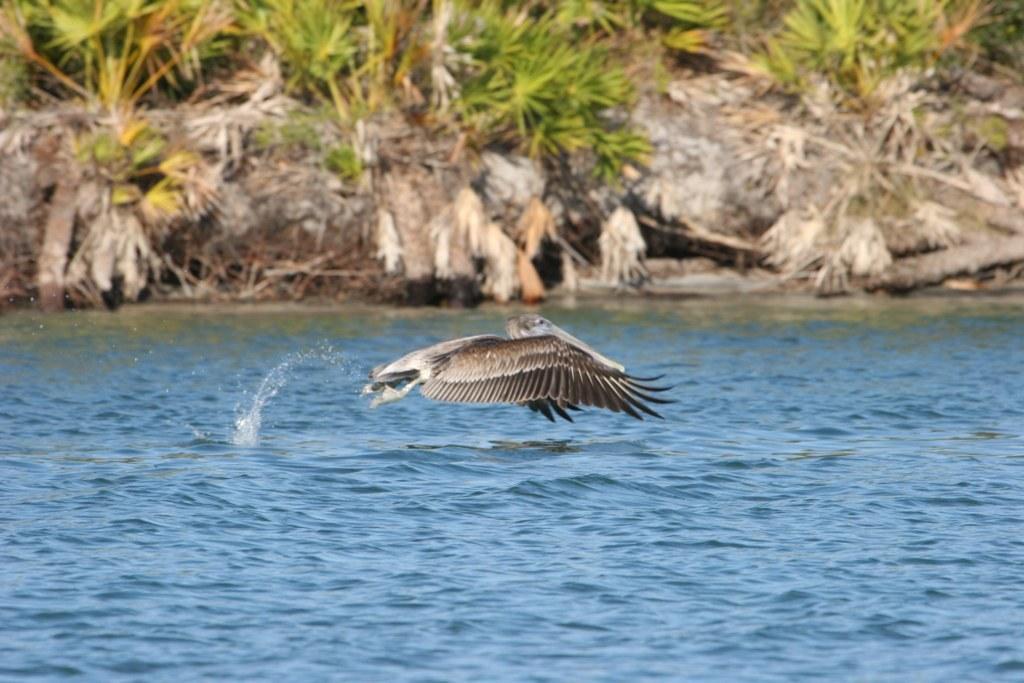Could you give a brief overview of what you see in this image? In this image at the bottom there is a river, and in the center there is one bird flying. And in the background there are some trees, and some dry plants and some sticks. 